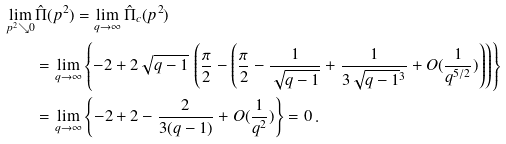Convert formula to latex. <formula><loc_0><loc_0><loc_500><loc_500>\lim _ { p ^ { 2 } \searrow 0 } & \hat { \Pi } ( p ^ { 2 } ) = \lim _ { q \to \infty } \hat { \Pi } _ { c } ( p ^ { 2 } ) \\ & = \lim _ { q \to \infty } \left \{ - 2 + 2 \sqrt { q - 1 } \, \left ( \frac { \pi } { 2 } - \left ( \frac { \pi } { 2 } - \frac { 1 } { \sqrt { q - 1 } } + \frac { 1 } { 3 \sqrt { q - 1 } ^ { 3 } } + O ( \frac { 1 } { q ^ { 5 / 2 } } ) \right ) \right ) \right \} \\ & = \lim _ { q \to \infty } \left \{ - 2 + 2 - \frac { 2 } { 3 ( q - 1 ) } + O ( \frac { 1 } { q ^ { 2 } } ) \right \} = 0 \, .</formula> 